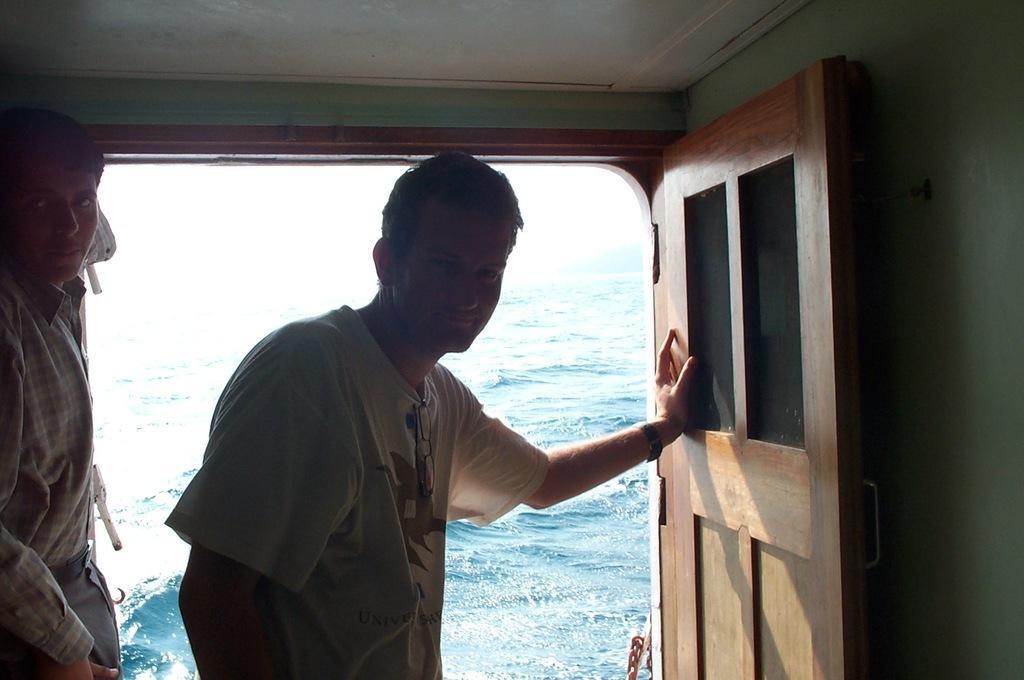In one or two sentences, can you explain what this image depicts? In this image, It looks like a ship. I can see two persons standing inside a ship and there is a door. In the background, there is water. 